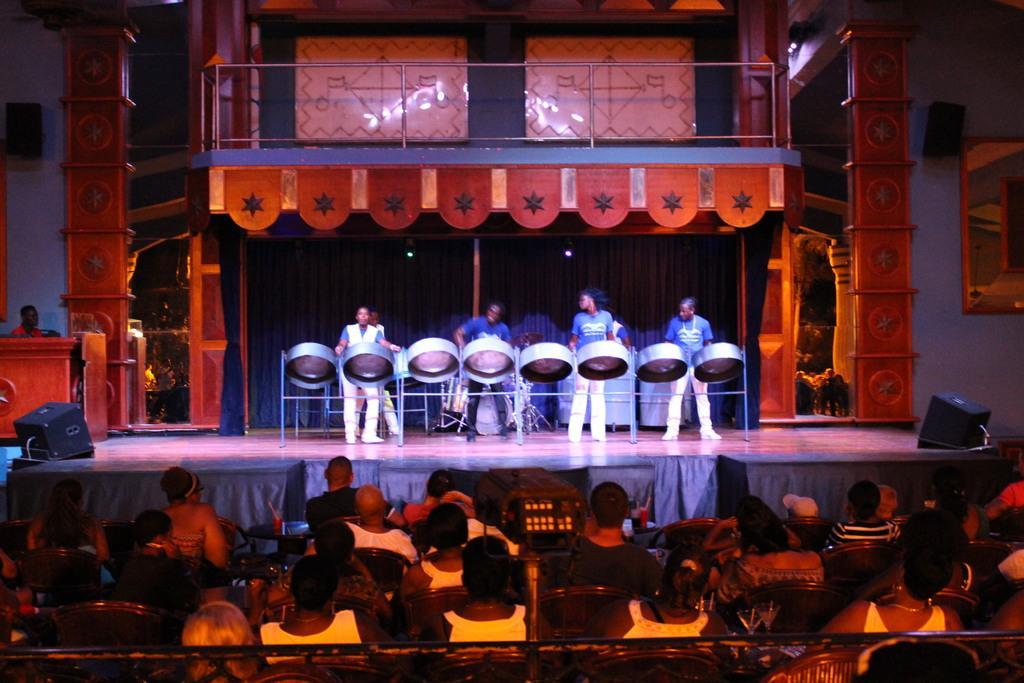Describe this image in one or two sentences. In this picture I can see group of people sitting on the chairs, there are group of people playing the musical instruments, there are speakers and some other objects. 